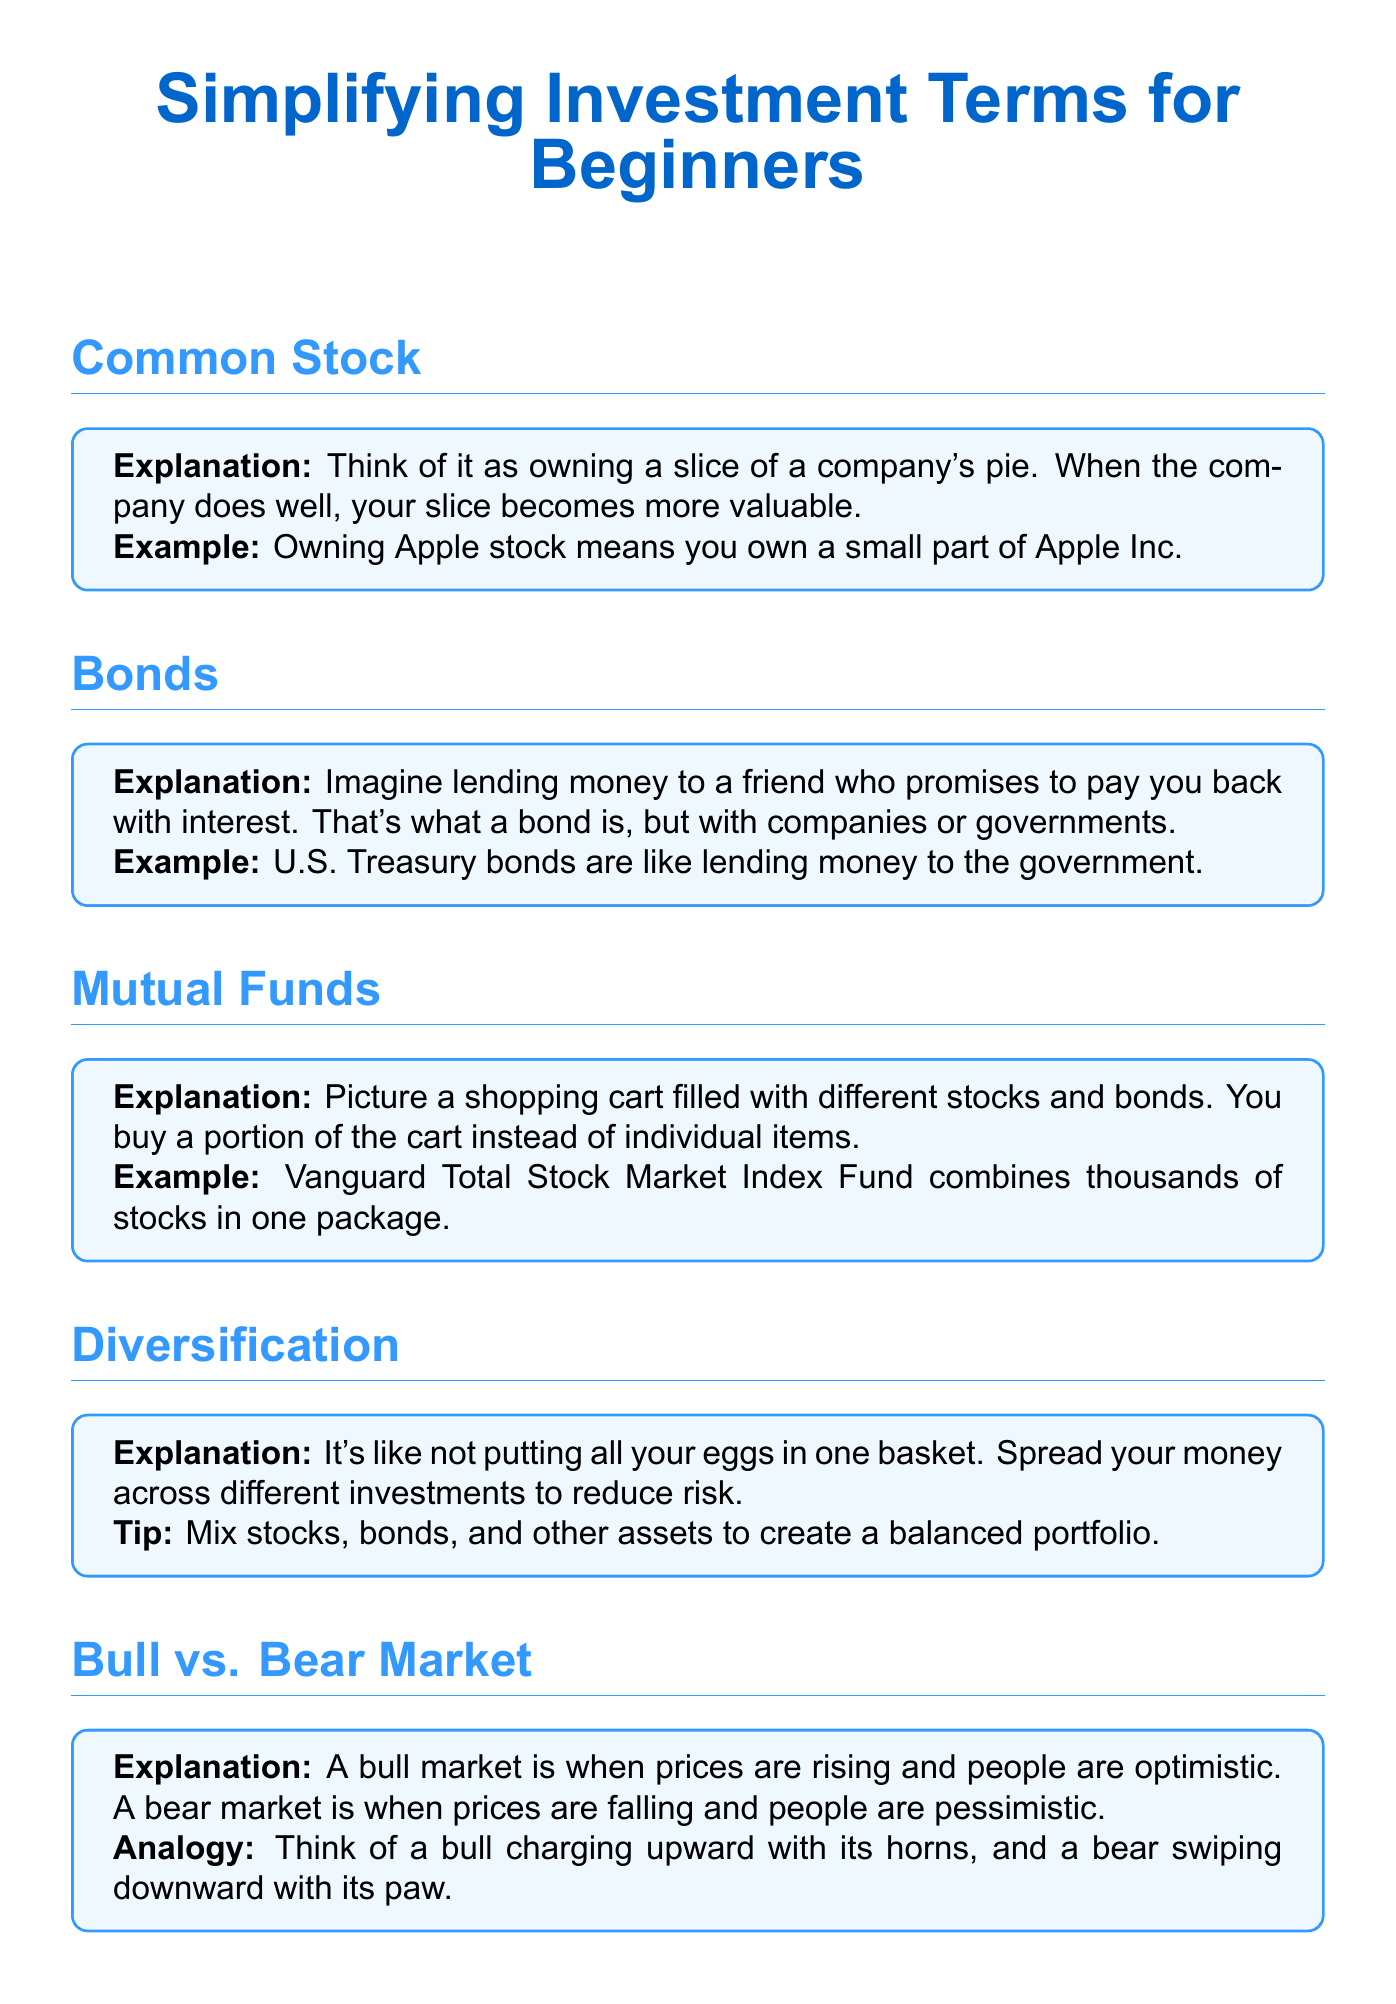What is the main title of the document? The title is the primary subject under which all the information is organized in the document.
Answer: Simplifying Investment Terms for Beginners What is the explanation for Common Stock? The explanation provides a basic understanding of a particular term used in investing.
Answer: Think of it as owning a slice of a company's pie. When the company does well, your slice becomes more valuable What analogy is used for a Bull Market? The analogy helps visualize and understand the concept of a bull market.
Answer: Think of a bull charging upward with its horns What investment type is compared to a shopping cart? This comparison illustrates how mutual funds work in a simple way.
Answer: Mutual Funds How does the document suggest spreading investments? This guidance helps reduce investment risk by using clear, relatable terms.
Answer: Not putting all your eggs in one basket What is a key tip for Diversification? The key tip provides practical advice on creating a balanced investment portfolio.
Answer: Mix stocks, bonds, and other assets to create a balanced portfolio In which type of market are prices rising? Identifying market trends is crucial for investors to make informed decisions.
Answer: Bull Market What example is given for Bonds? A concrete example helps clarify what bonds are to new investors.
Answer: U.S. Treasury bonds What should you consider according to the conclusion? The conclusion summarizes important takeaways for effective investing.
Answer: Invest within your risk tolerance and for the long term 